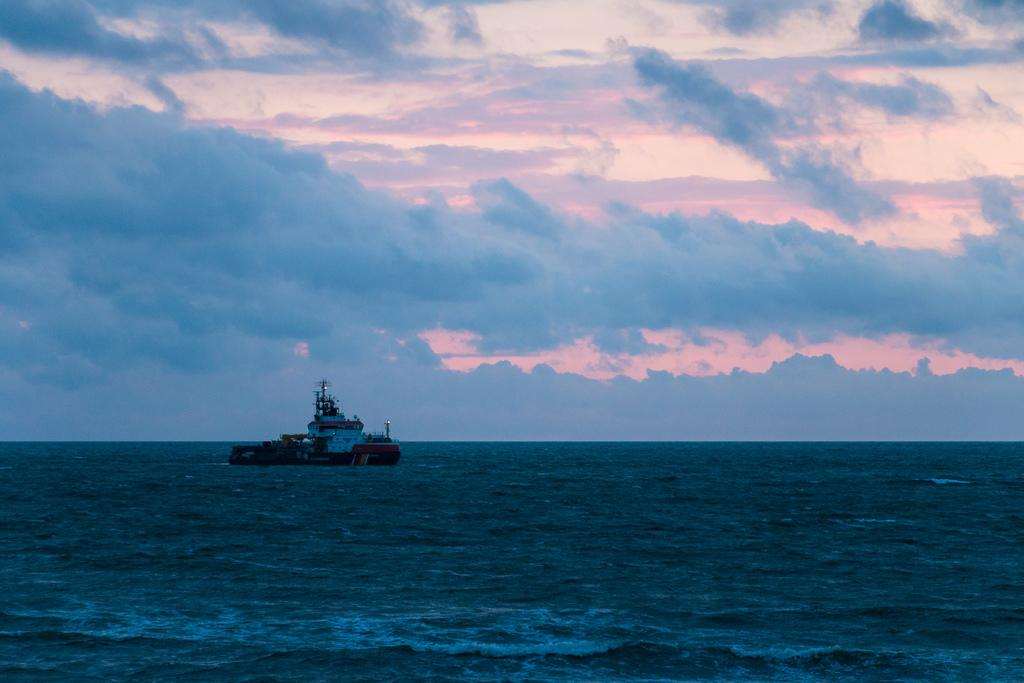What is in the water in the image? There is a boat in the water in the image. What else can be seen in the image besides the boat? The sky is visible in the image. What type of pear is being discussed in the image? There is no pear present in the image; it only features a boat in the water and the sky. 